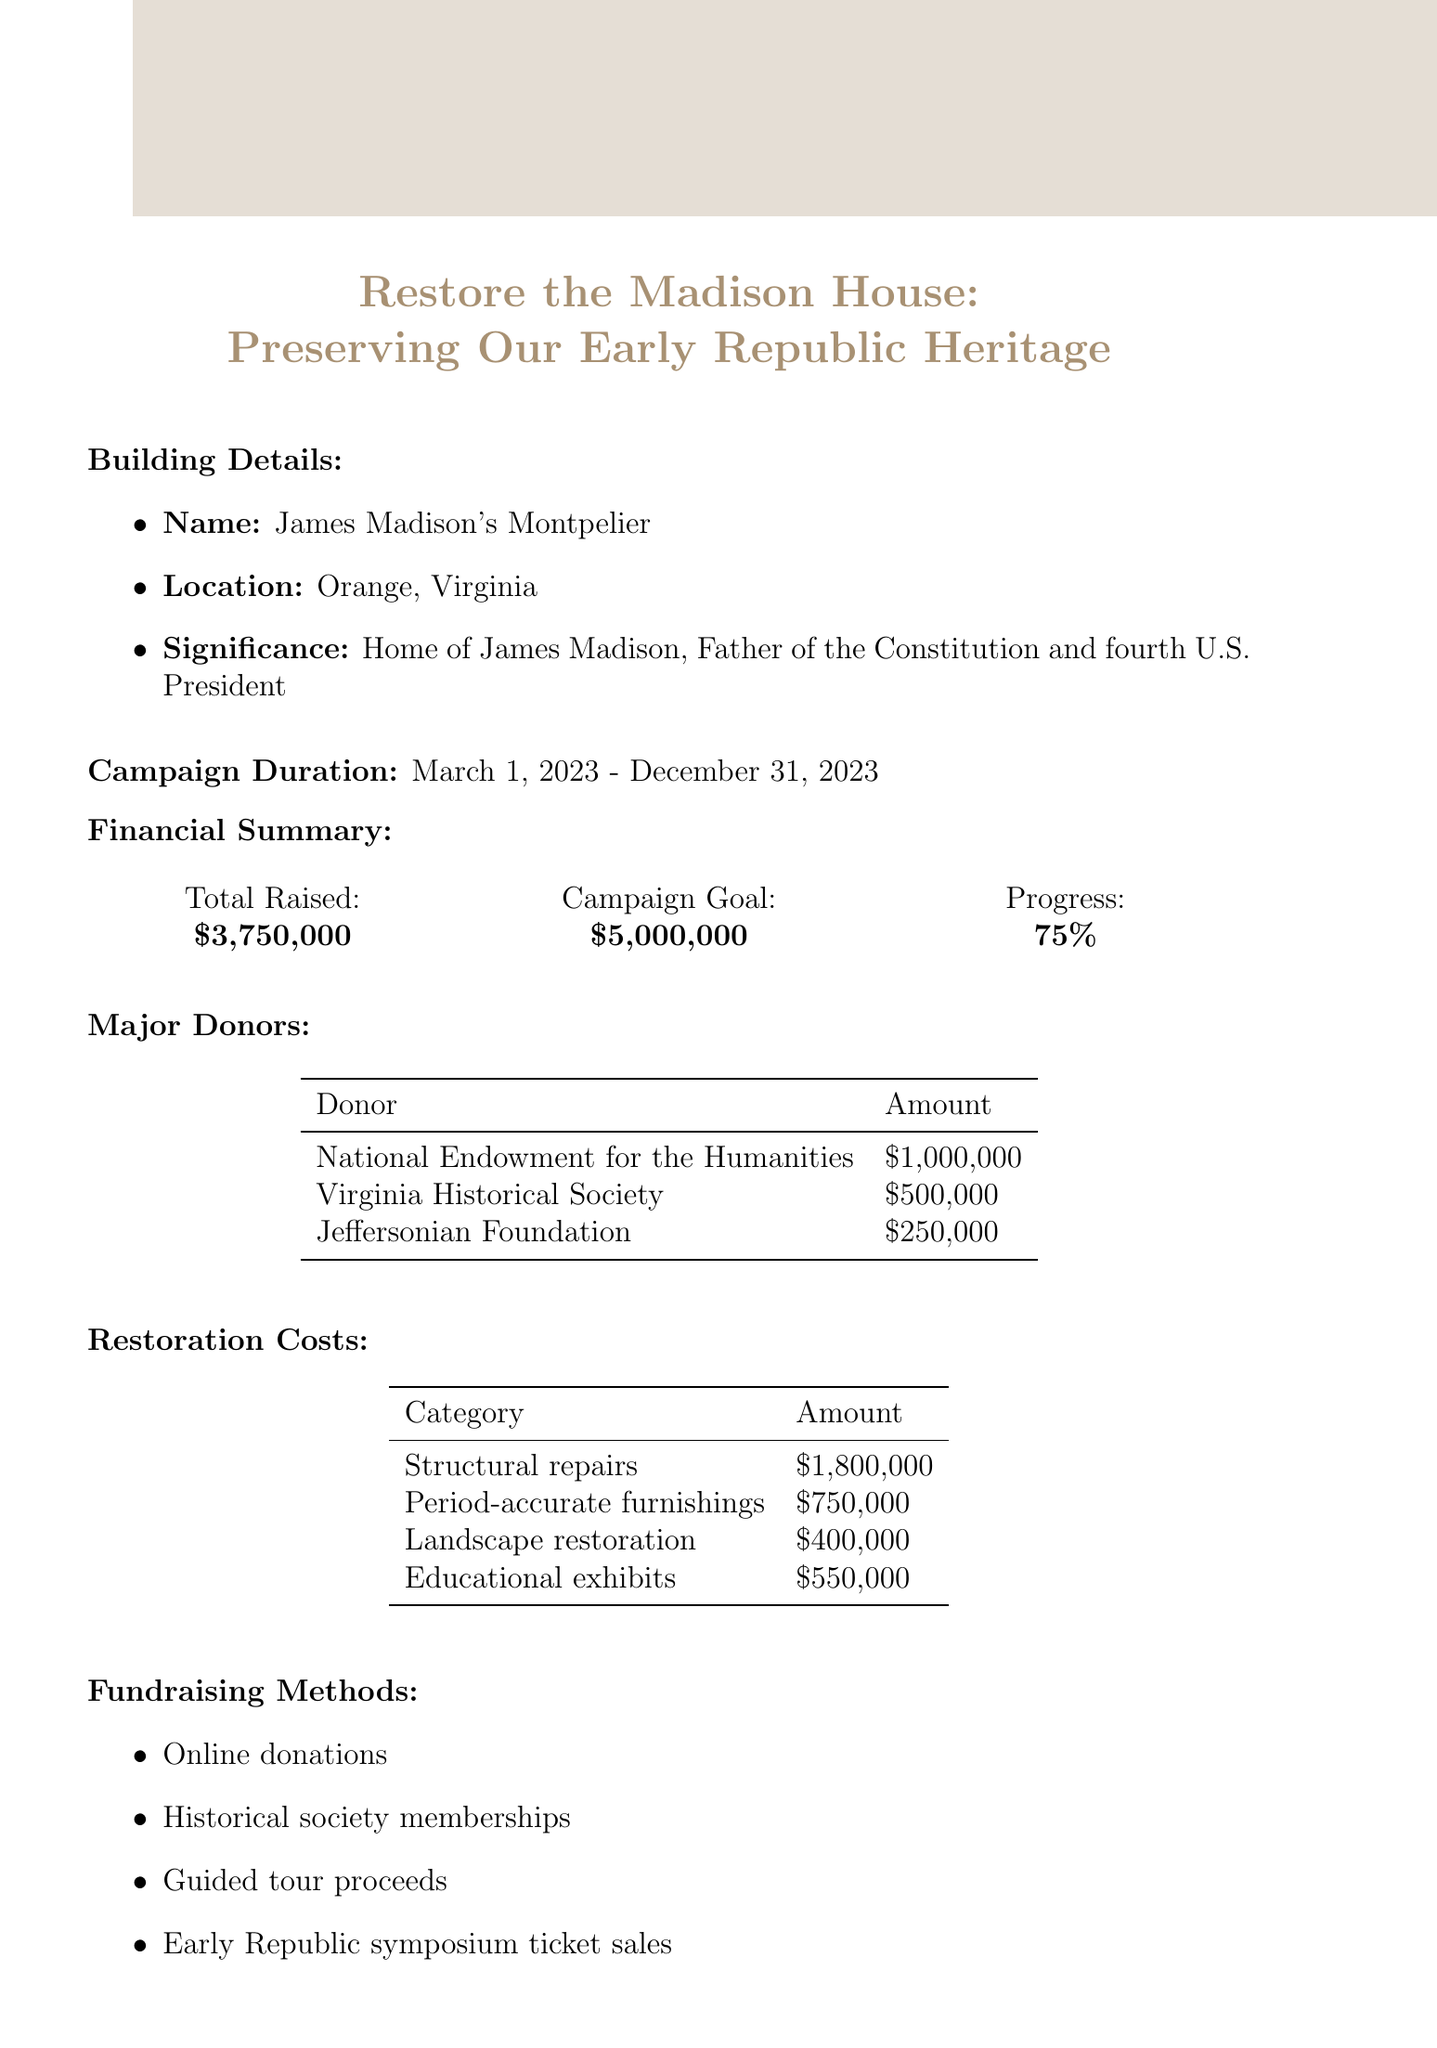What is the total funds raised? The total funds raised is provided in the financial summary section as $3,750,000.
Answer: $3,750,000 What is the campaign goal? The campaign goal is outlined in the financial summary section as $5,000,000.
Answer: $5,000,000 Which organization contributed the highest amount? The major donors section lists the National Endowment for the Humanities as contributing $1,000,000, the highest amount among the listed donors.
Answer: National Endowment for the Humanities What is the cost for structural repairs? The restoration costs section specifies the amount for structural repairs as $1,800,000.
Answer: $1,800,000 What percentage of the campaign goal has been achieved? The percentage achieved is indicated in the financial summary section as 75%.
Answer: 75% Which fundraising method involves ticket sales? The fundraising methods section mentions "Early Republic symposium ticket sales" as one of the methods that involve ticket sales.
Answer: Early Republic symposium ticket sales How many categories are listed under restoration costs? The restoration costs section presents a total of four categories for the costs.
Answer: 4 What is the historical significance of James Madison's Montpelier? The historical significance is described as being the home of James Madison, the Father of the Constitution and fourth U.S. President.
Answer: Home of James Madison, Father of the Constitution and fourth U.S. President What is the location of the building being restored? The document specifies the location of James Madison's Montpelier as Orange, Virginia.
Answer: Orange, Virginia 